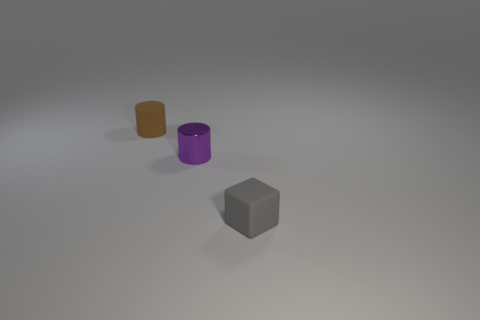The tiny matte cylinder has what color?
Provide a short and direct response. Brown. There is a cylinder on the right side of the matte thing behind the tiny matte thing in front of the small brown thing; what size is it?
Your response must be concise. Small. How many other objects are the same shape as the shiny thing?
Your answer should be very brief. 1. What color is the small object that is left of the gray object and to the right of the small brown rubber cylinder?
Your response must be concise. Purple. Are there any other things that have the same size as the purple object?
Keep it short and to the point. Yes. There is a small rubber thing behind the gray rubber block; is its color the same as the rubber block?
Make the answer very short. No. How many blocks are either small purple shiny objects or tiny gray objects?
Offer a terse response. 1. What is the shape of the tiny rubber thing behind the gray thing?
Ensure brevity in your answer.  Cylinder. There is a small matte thing behind the tiny rubber block that is right of the small matte thing that is behind the matte block; what is its color?
Give a very brief answer. Brown. Do the small cube and the small purple object have the same material?
Offer a terse response. No. 